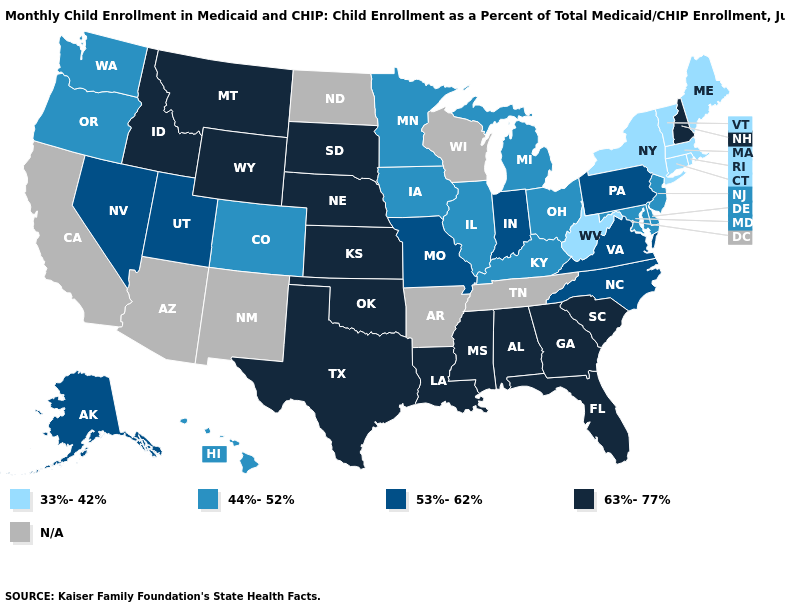Does the first symbol in the legend represent the smallest category?
Write a very short answer. Yes. What is the value of Pennsylvania?
Give a very brief answer. 53%-62%. Name the states that have a value in the range 53%-62%?
Be succinct. Alaska, Indiana, Missouri, Nevada, North Carolina, Pennsylvania, Utah, Virginia. Name the states that have a value in the range 44%-52%?
Short answer required. Colorado, Delaware, Hawaii, Illinois, Iowa, Kentucky, Maryland, Michigan, Minnesota, New Jersey, Ohio, Oregon, Washington. Name the states that have a value in the range 33%-42%?
Give a very brief answer. Connecticut, Maine, Massachusetts, New York, Rhode Island, Vermont, West Virginia. What is the highest value in states that border Maryland?
Write a very short answer. 53%-62%. Name the states that have a value in the range 53%-62%?
Keep it brief. Alaska, Indiana, Missouri, Nevada, North Carolina, Pennsylvania, Utah, Virginia. Which states have the lowest value in the South?
Give a very brief answer. West Virginia. Which states have the highest value in the USA?
Give a very brief answer. Alabama, Florida, Georgia, Idaho, Kansas, Louisiana, Mississippi, Montana, Nebraska, New Hampshire, Oklahoma, South Carolina, South Dakota, Texas, Wyoming. Does Massachusetts have the highest value in the USA?
Be succinct. No. What is the highest value in the MidWest ?
Quick response, please. 63%-77%. 